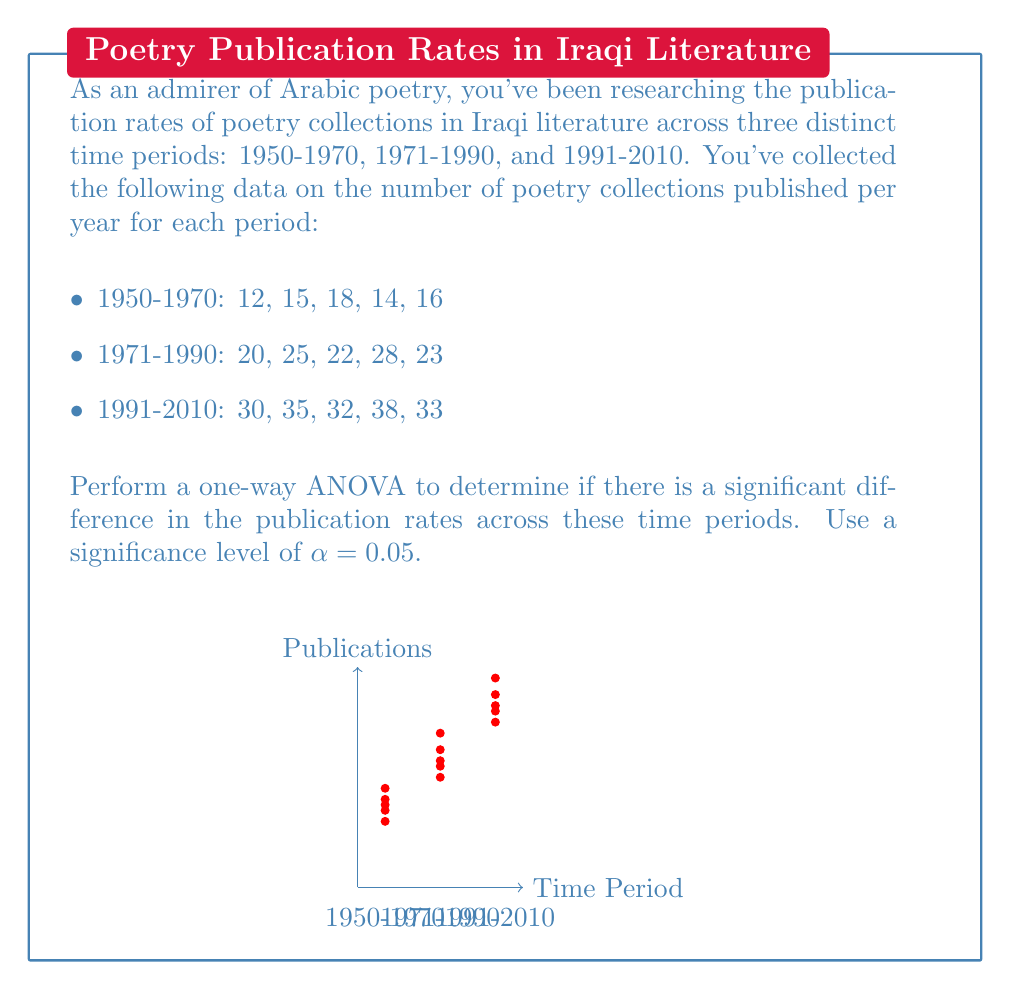Teach me how to tackle this problem. Let's perform the one-way ANOVA step-by-step:

1) First, calculate the means for each group:

   $\bar{X}_1 = \frac{12 + 15 + 18 + 14 + 16}{5} = 15$
   $\bar{X}_2 = \frac{20 + 25 + 22 + 28 + 23}{5} = 23.6$
   $\bar{X}_3 = \frac{30 + 35 + 32 + 38 + 33}{5} = 33.6$

2) Calculate the grand mean:

   $\bar{X} = \frac{15 + 23.6 + 33.6}{3} = 24.07$

3) Calculate the Sum of Squares Between groups (SSB):

   $SSB = 5[(15 - 24.07)^2 + (23.6 - 24.07)^2 + (33.6 - 24.07)^2] = 1035.43$

4) Calculate the Sum of Squares Within groups (SSW):

   $SSW_1 = (12-15)^2 + (15-15)^2 + (18-15)^2 + (14-15)^2 + (16-15)^2 = 20$
   $SSW_2 = (20-23.6)^2 + (25-23.6)^2 + (22-23.6)^2 + (28-23.6)^2 + (23-23.6)^2 = 44.8$
   $SSW_3 = (30-33.6)^2 + (35-33.6)^2 + (32-33.6)^2 + (38-33.6)^2 + (33-33.6)^2 = 44.8$

   $SSW = 20 + 44.8 + 44.8 = 109.6$

5) Calculate degrees of freedom:

   $df_{between} = k - 1 = 3 - 1 = 2$
   $df_{within} = N - k = 15 - 3 = 12$

6) Calculate Mean Square Between (MSB) and Mean Square Within (MSW):

   $MSB = \frac{SSB}{df_{between}} = \frac{1035.43}{2} = 517.715$
   $MSW = \frac{SSW}{df_{within}} = \frac{109.6}{12} = 9.13$

7) Calculate the F-statistic:

   $F = \frac{MSB}{MSW} = \frac{517.715}{9.13} = 56.70$

8) Find the critical F-value:

   For α = 0.05, $df_{between} = 2$, and $df_{within} = 12$, the critical F-value is approximately 3.89.

9) Compare the F-statistic to the critical F-value:

   Since 56.70 > 3.89, we reject the null hypothesis.
Answer: $F(2,12) = 56.70, p < 0.05$. Significant difference in publication rates across time periods. 